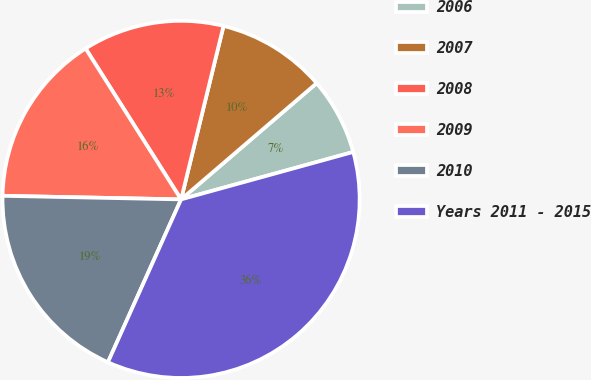<chart> <loc_0><loc_0><loc_500><loc_500><pie_chart><fcel>2006<fcel>2007<fcel>2008<fcel>2009<fcel>2010<fcel>Years 2011 - 2015<nl><fcel>7.0%<fcel>9.9%<fcel>12.8%<fcel>15.7%<fcel>18.6%<fcel>36.0%<nl></chart> 